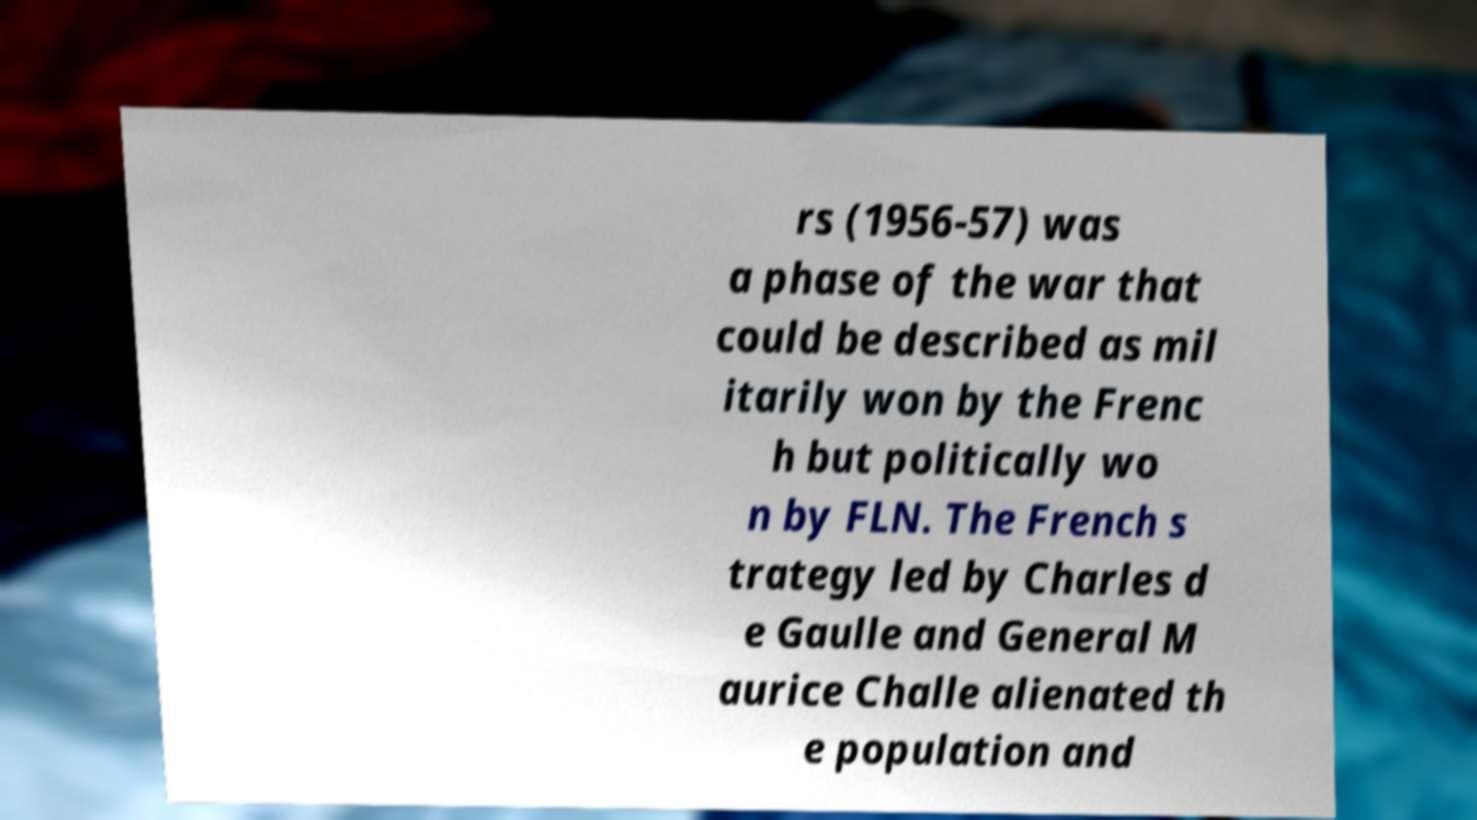For documentation purposes, I need the text within this image transcribed. Could you provide that? rs (1956-57) was a phase of the war that could be described as mil itarily won by the Frenc h but politically wo n by FLN. The French s trategy led by Charles d e Gaulle and General M aurice Challe alienated th e population and 